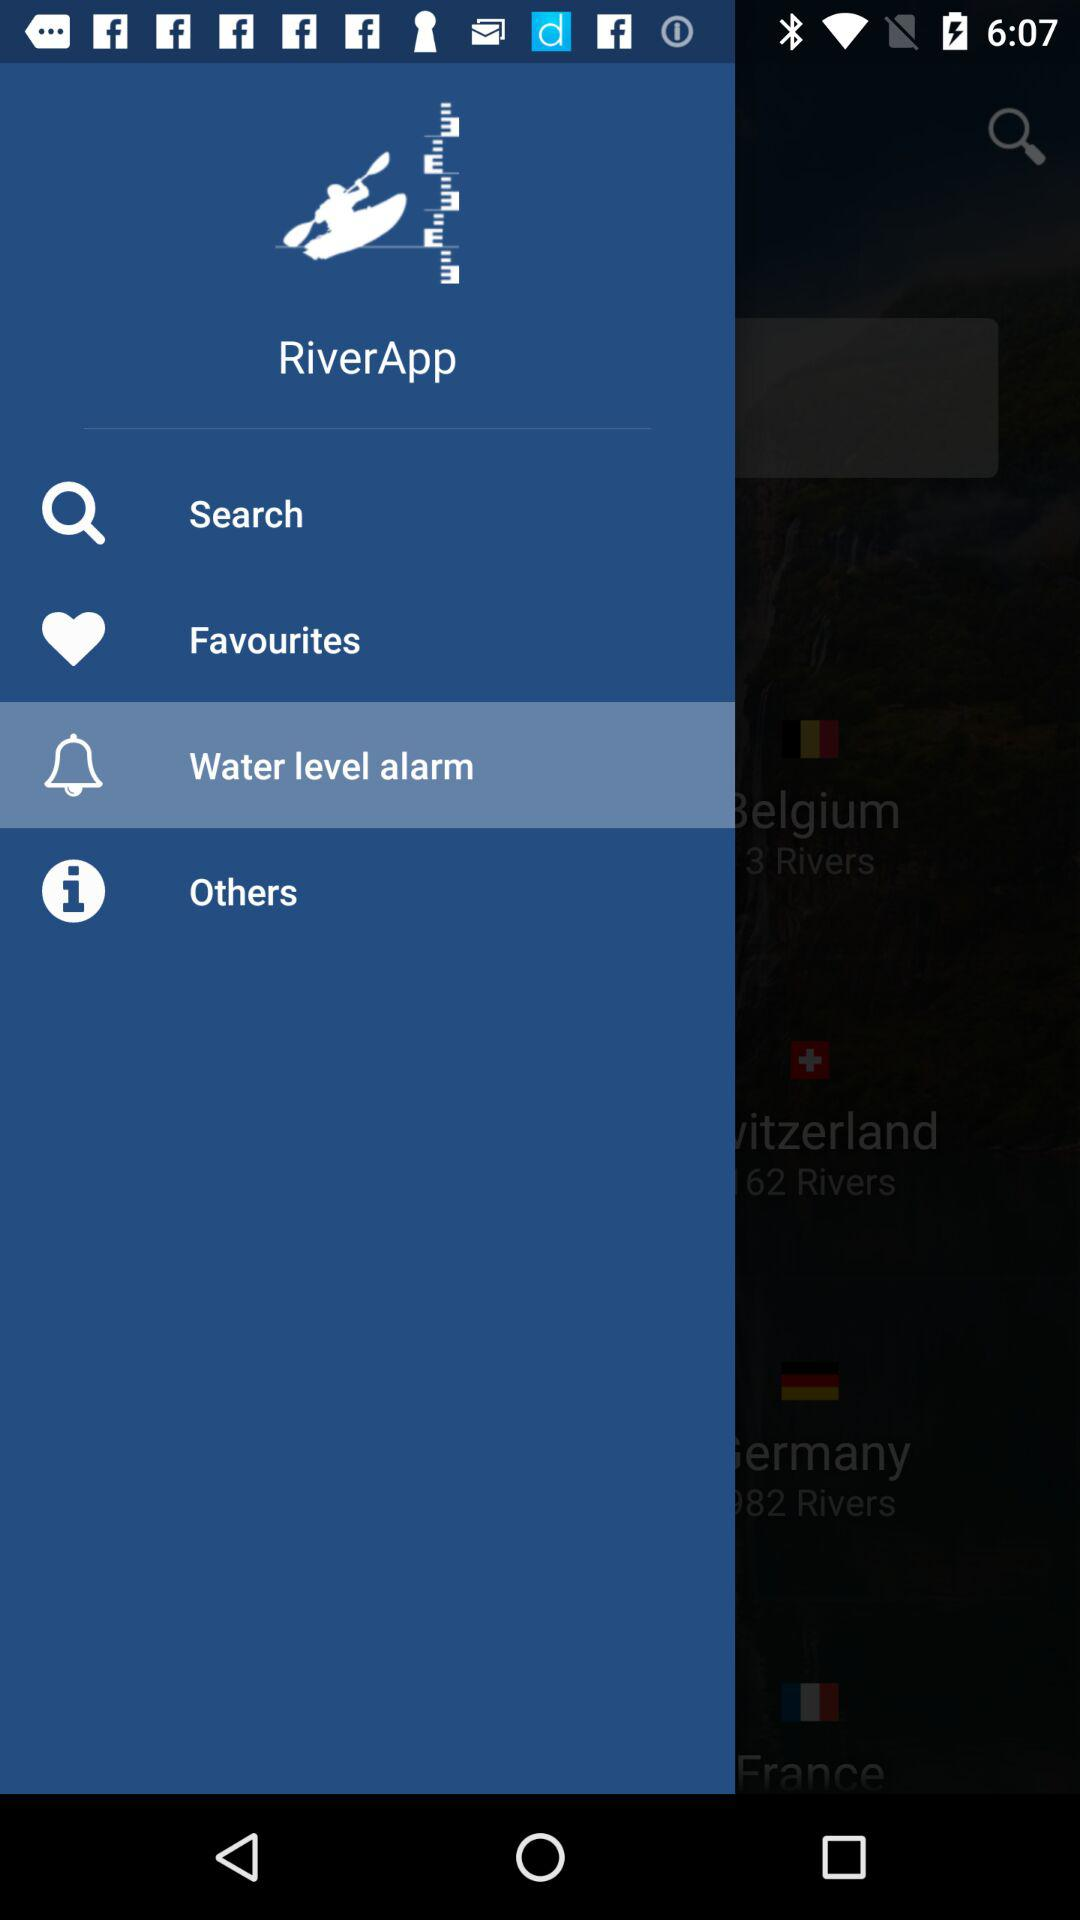What is the name of the application? The name of the application is "RiverApp". 